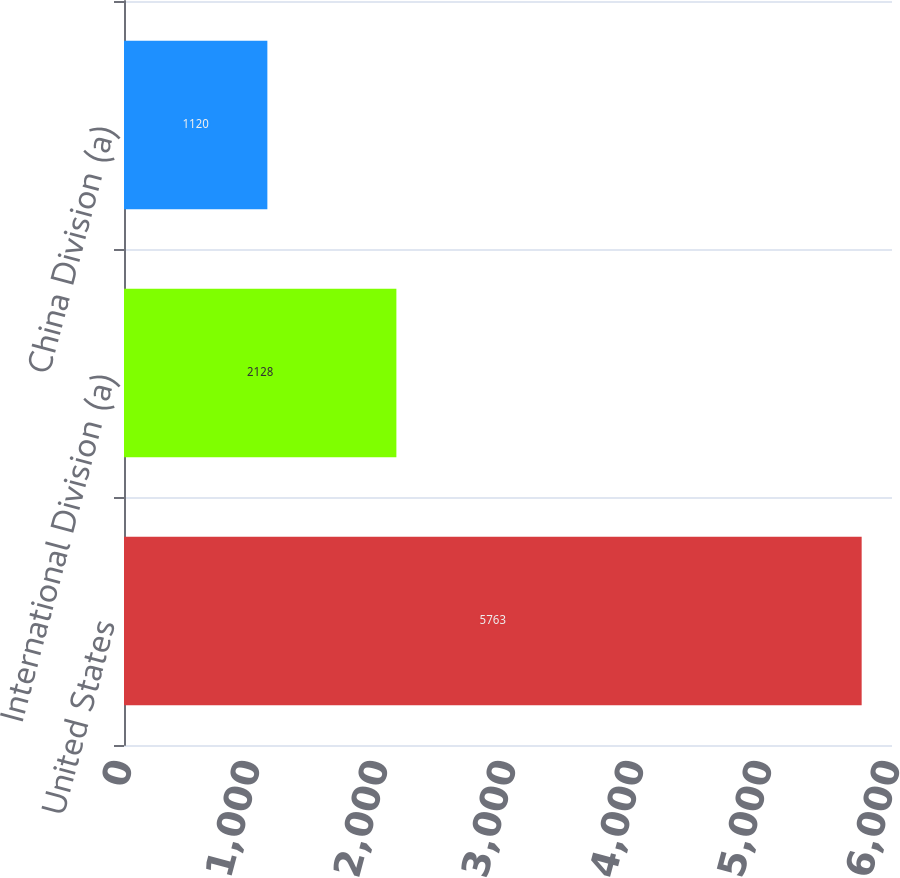Convert chart. <chart><loc_0><loc_0><loc_500><loc_500><bar_chart><fcel>United States<fcel>International Division (a)<fcel>China Division (a)<nl><fcel>5763<fcel>2128<fcel>1120<nl></chart> 